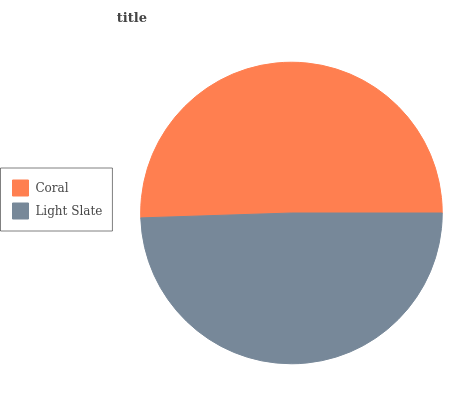Is Light Slate the minimum?
Answer yes or no. Yes. Is Coral the maximum?
Answer yes or no. Yes. Is Light Slate the maximum?
Answer yes or no. No. Is Coral greater than Light Slate?
Answer yes or no. Yes. Is Light Slate less than Coral?
Answer yes or no. Yes. Is Light Slate greater than Coral?
Answer yes or no. No. Is Coral less than Light Slate?
Answer yes or no. No. Is Coral the high median?
Answer yes or no. Yes. Is Light Slate the low median?
Answer yes or no. Yes. Is Light Slate the high median?
Answer yes or no. No. Is Coral the low median?
Answer yes or no. No. 